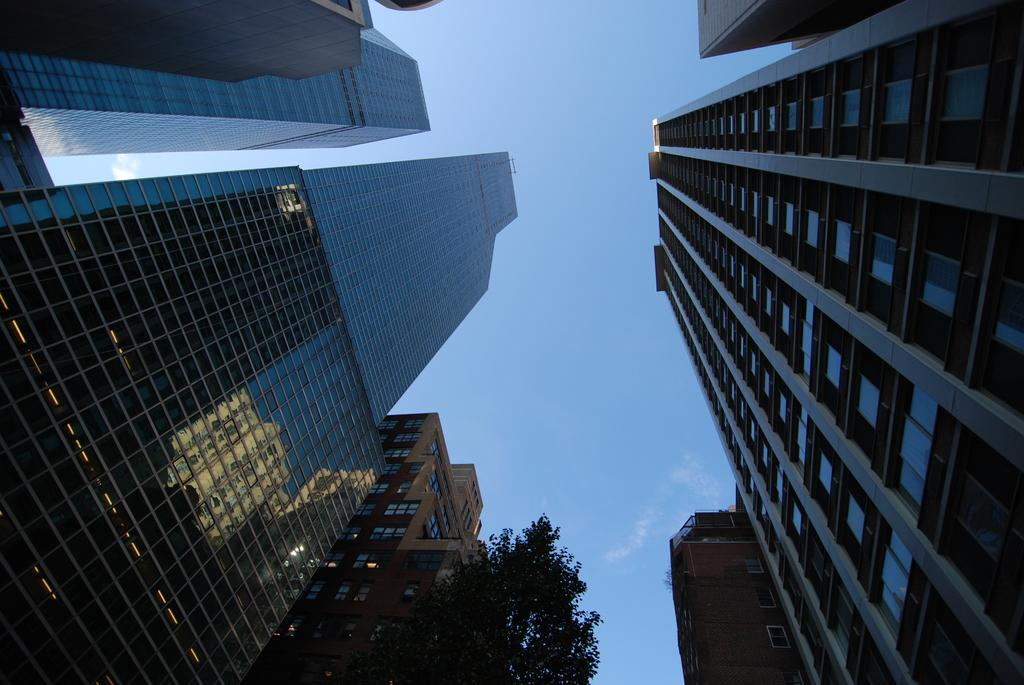What type of buildings can be seen in the image? There are tower buildings with many floors in the image. What material is used on the buildings? The buildings have glass on them. What is located near the buildings? There is a tree beside the buildings. What is visible in the background of the image? The sky is visible in the image. What can be seen in the sky? Clouds are present in the sky. What type of wood can be seen in the image? There is no wood present in the image; the buildings have glass on them. Is it raining in the image? The image does not show any indication of rain; it only shows clouds in the sky. 